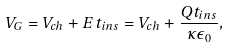Convert formula to latex. <formula><loc_0><loc_0><loc_500><loc_500>V _ { G } = V _ { c h } + E \, t _ { i n s } = V _ { c h } + { \frac { Q t _ { i n s } } { \kappa \epsilon _ { 0 } } } ,</formula> 